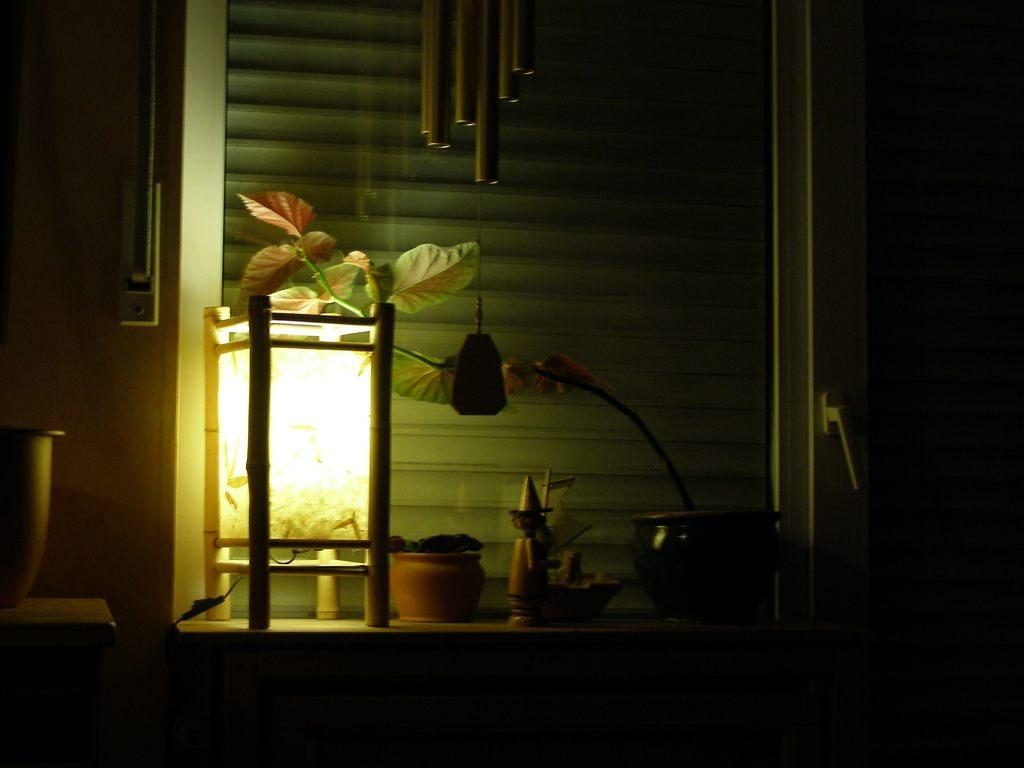What piece of furniture is present in the image? There is a table in the image. What is placed on the table? There is a lamp and a house plant on the table. Can you describe the flower pot in the image? The flower pot is in the image, and it is hanging. What is visible through the window in the image? Unfortunately, the facts provided do not mention anything visible through the window. What type of pets can be seen playing with paste in the image? There are no pets or paste present in the image. 